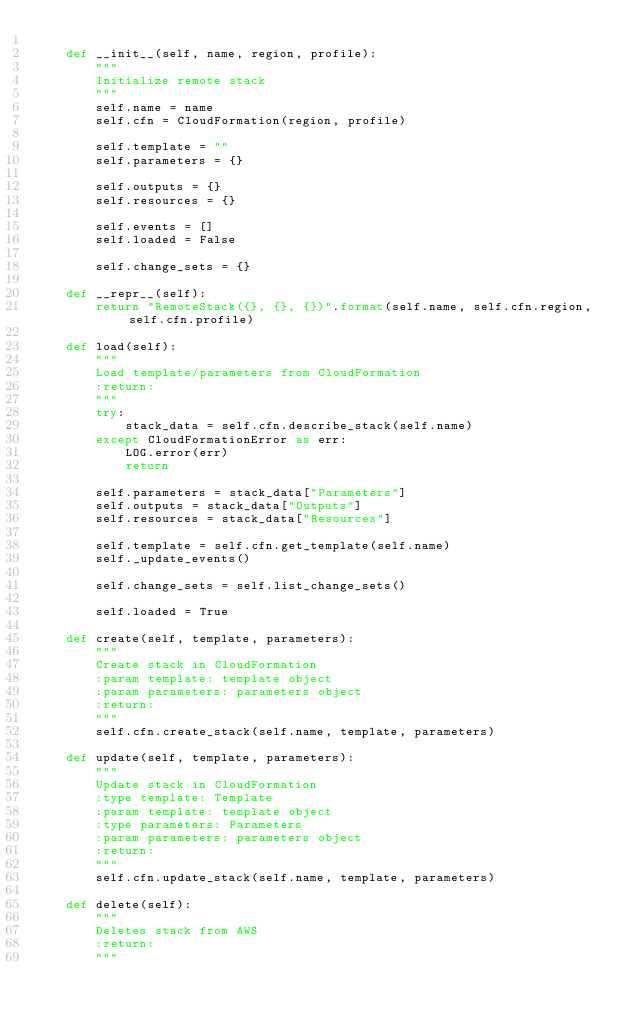Convert code to text. <code><loc_0><loc_0><loc_500><loc_500><_Python_>
    def __init__(self, name, region, profile):
        """
        Initialize remote stack
        """
        self.name = name
        self.cfn = CloudFormation(region, profile)

        self.template = ""
        self.parameters = {}

        self.outputs = {}
        self.resources = {}

        self.events = []
        self.loaded = False

        self.change_sets = {}

    def __repr__(self):
        return "RemoteStack({}, {}, {})".format(self.name, self.cfn.region, self.cfn.profile)

    def load(self):
        """
        Load template/parameters from CloudFormation
        :return:
        """
        try:
            stack_data = self.cfn.describe_stack(self.name)
        except CloudFormationError as err:
            LOG.error(err)
            return

        self.parameters = stack_data["Parameters"]
        self.outputs = stack_data["Outputs"]
        self.resources = stack_data["Resources"]

        self.template = self.cfn.get_template(self.name)
        self._update_events()

        self.change_sets = self.list_change_sets()

        self.loaded = True

    def create(self, template, parameters):
        """
        Create stack in CloudFormation
        :param template: template object
        :param parameters: parameters object
        :return:
        """
        self.cfn.create_stack(self.name, template, parameters)

    def update(self, template, parameters):
        """
        Update stack in CloudFormation
        :type template: Template
        :param template: template object
        :type parameters: Parameters
        :param parameters: parameters object
        :return:
        """
        self.cfn.update_stack(self.name, template, parameters)

    def delete(self):
        """
        Deletes stack from AWS
        :return:
        """</code> 